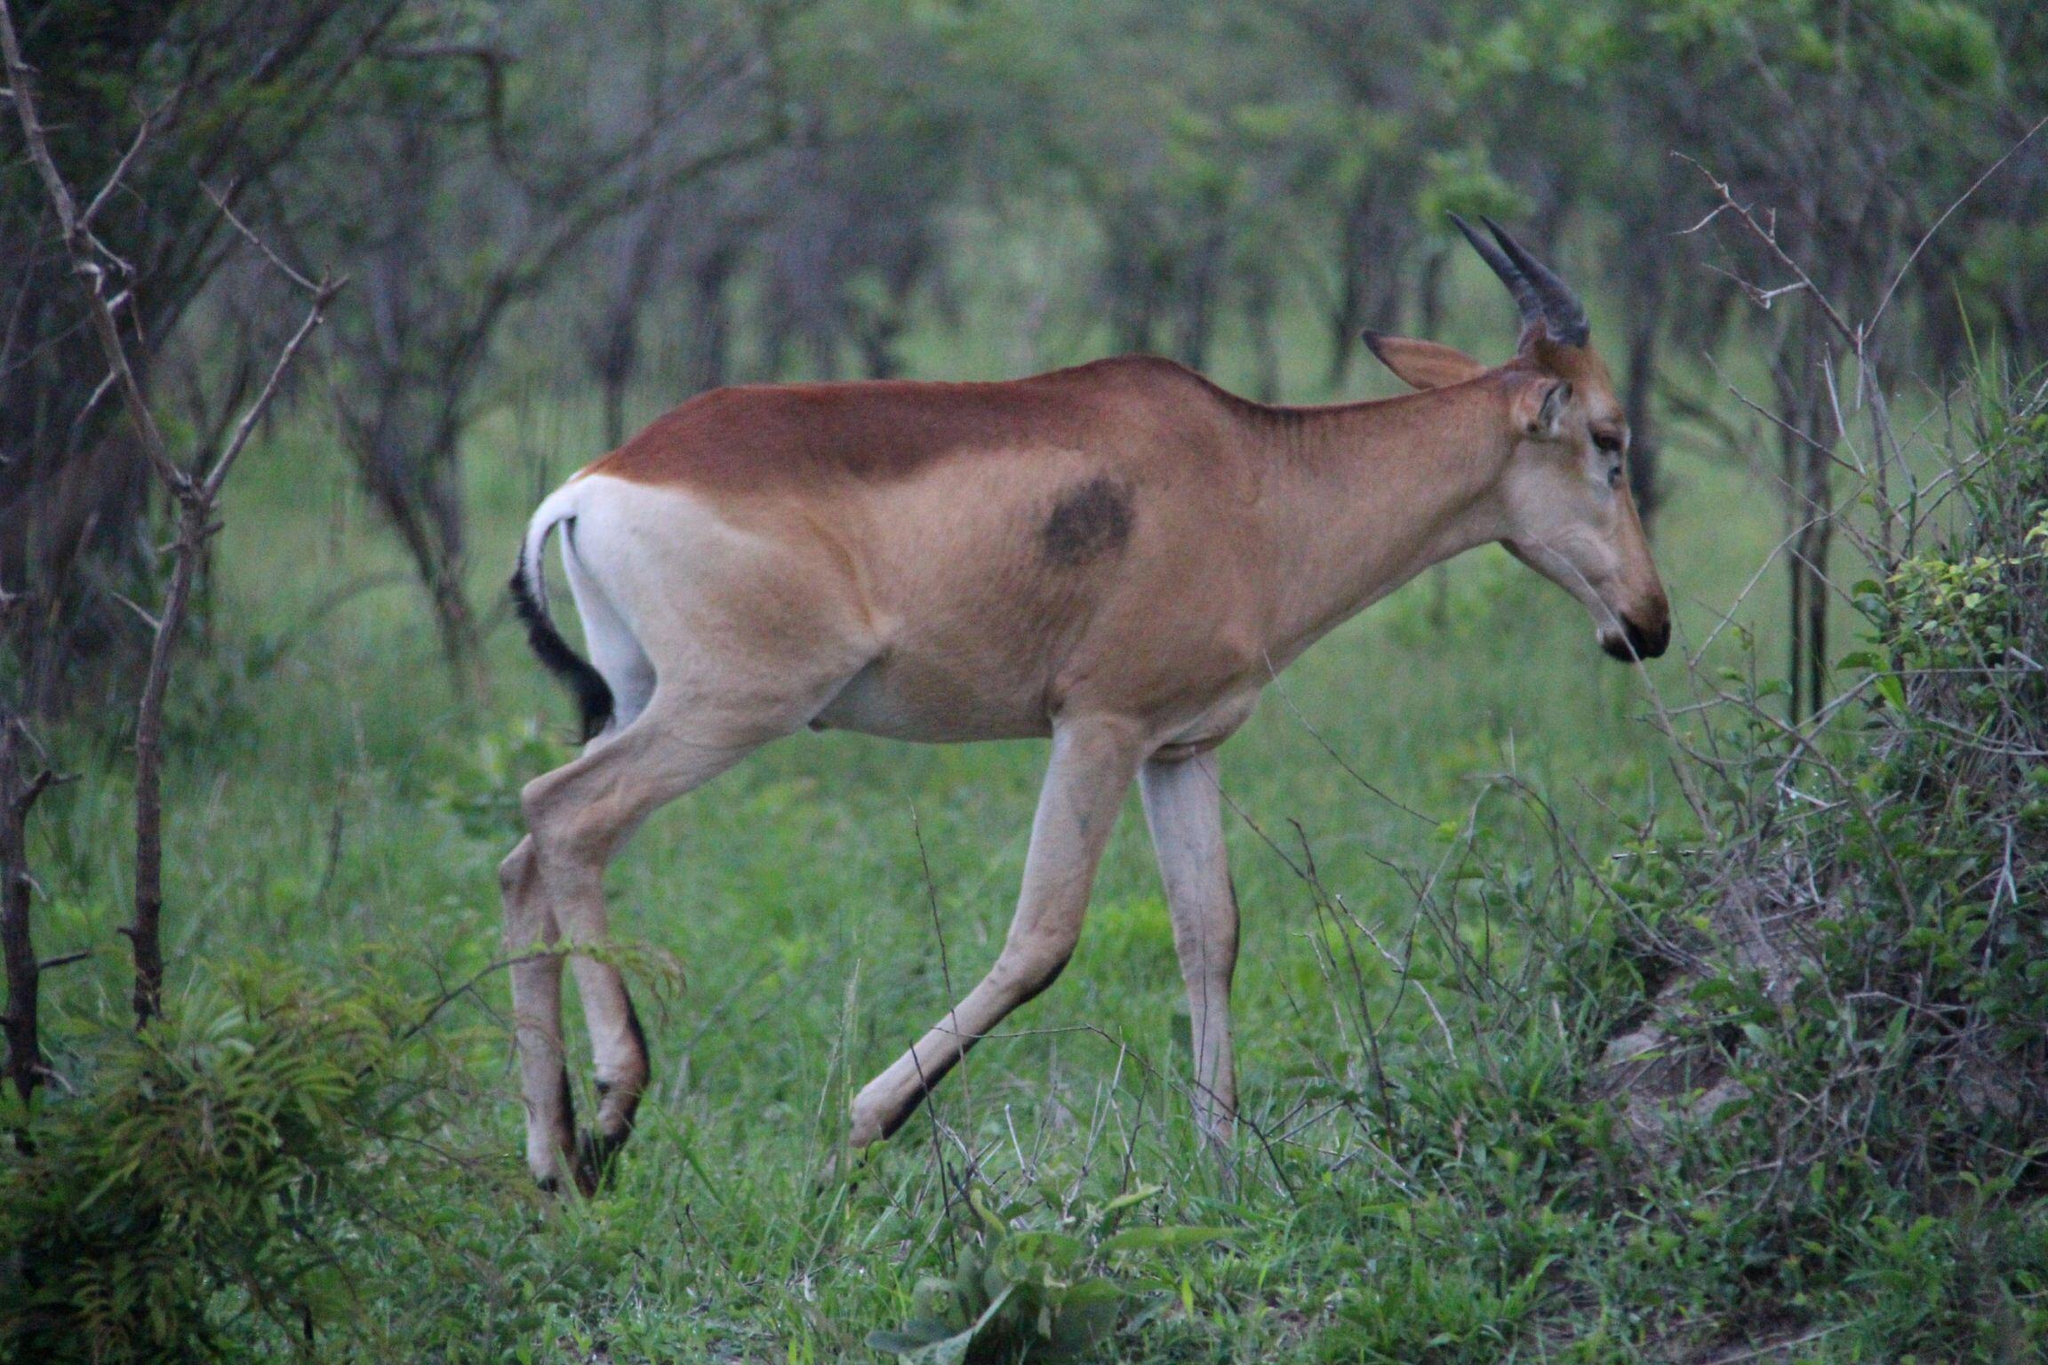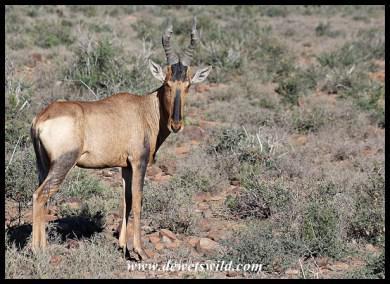The first image is the image on the left, the second image is the image on the right. Examine the images to the left and right. Is the description "One image contains at least one hornless deer-like animal with vertical white stripes, and the other image features multiple animals with curved horns and at least one reclining animal." accurate? Answer yes or no. No. The first image is the image on the left, the second image is the image on the right. Evaluate the accuracy of this statement regarding the images: "All the animals have horns.". Is it true? Answer yes or no. Yes. 